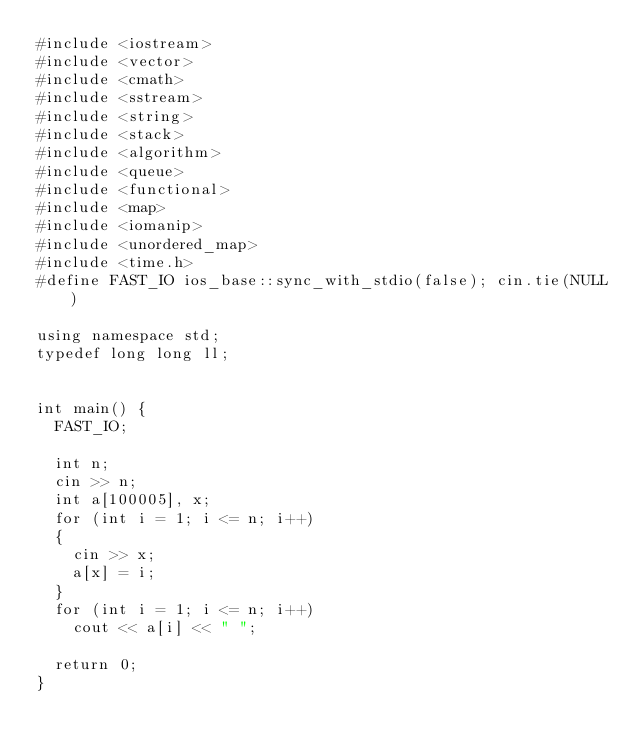Convert code to text. <code><loc_0><loc_0><loc_500><loc_500><_C++_>#include <iostream>
#include <vector>
#include <cmath>
#include <sstream>
#include <string>
#include <stack>
#include <algorithm>
#include <queue>
#include <functional>
#include <map>
#include <iomanip>
#include <unordered_map>
#include <time.h>
#define FAST_IO ios_base::sync_with_stdio(false); cin.tie(NULL)

using namespace std;
typedef long long ll;


int main() {
	FAST_IO;
	
	int n;
	cin >> n;
	int a[100005], x;
	for (int i = 1; i <= n; i++)
	{
		cin >> x;
		a[x] = i;
	}
	for (int i = 1; i <= n; i++)
		cout << a[i] << " ";

	return 0;
}

</code> 